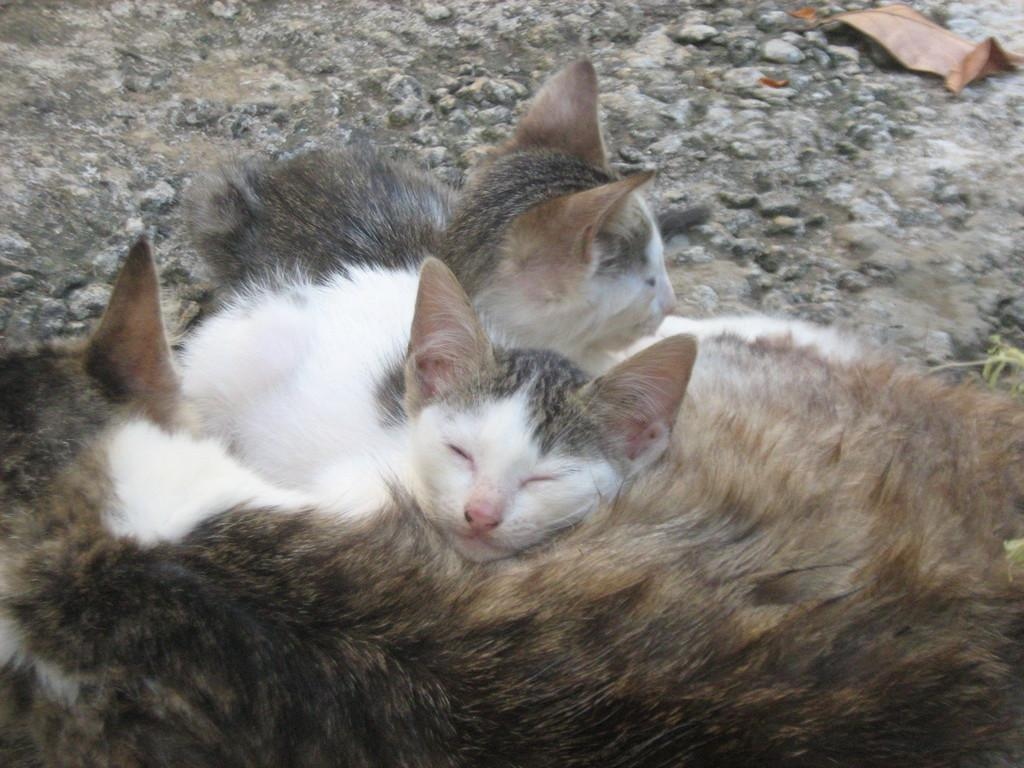What type of animals are in the image? There are cats in the image. Where are the cats located? The cats are on the land. What is the terrain of the land like? The land has rocks and dried leaves. What type of verse can be seen written on the rocks in the image? There is no verse written on the rocks in the image; the rocks are simply part of the land's terrain. What beliefs do the cats in the image hold? There is no information about the cats' beliefs in the image. Are there any cacti visible in the image? There is no mention of cacti in the provided facts about the image. 